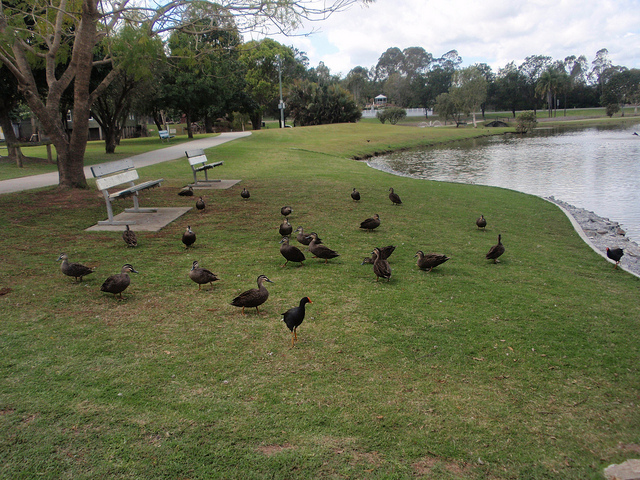<image>How is the fowl in the front center different from those behind it? I don't know how the fowl in the front center is different from those behind it. It can be due to color, size, or species. How is the fowl in the front center different from those behind it? I am not sure how the fowl in the front center is different from those behind it. It can be different in color, species or size. 